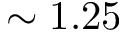Convert formula to latex. <formula><loc_0><loc_0><loc_500><loc_500>\sim 1 . 2 5</formula> 